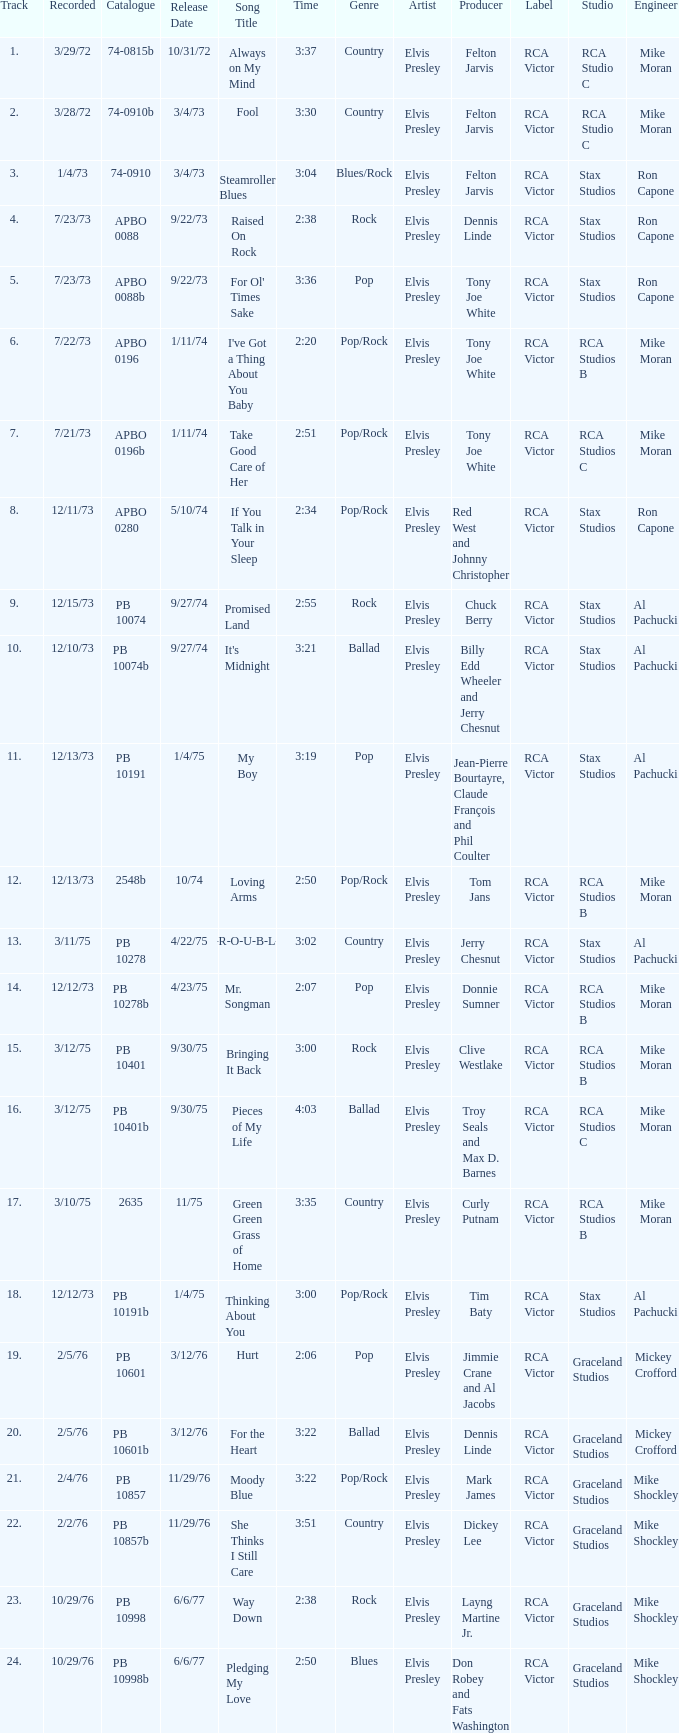Tell me the track that has the catalogue of apbo 0280 8.0. 